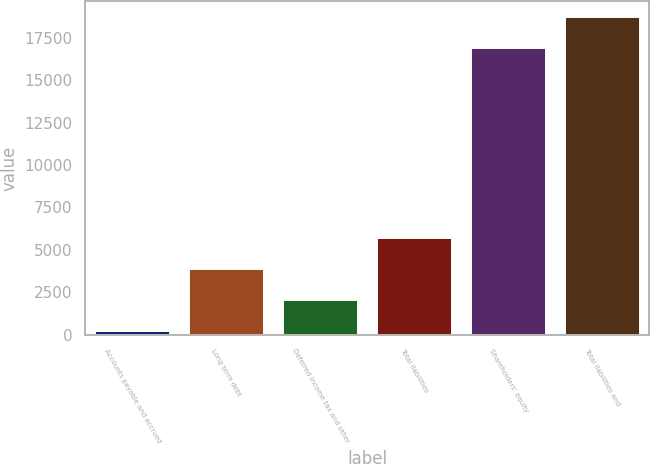Convert chart. <chart><loc_0><loc_0><loc_500><loc_500><bar_chart><fcel>Accounts payable and accrued<fcel>Long term debt<fcel>Deferred income tax and other<fcel>Total liabilities<fcel>Shareholders' equity<fcel>Total liabilities and<nl><fcel>202<fcel>3849.4<fcel>2025.7<fcel>5673.1<fcel>16899<fcel>18722.7<nl></chart> 